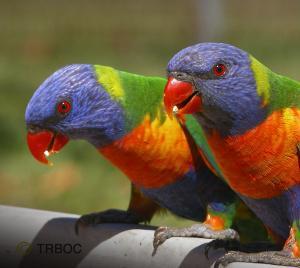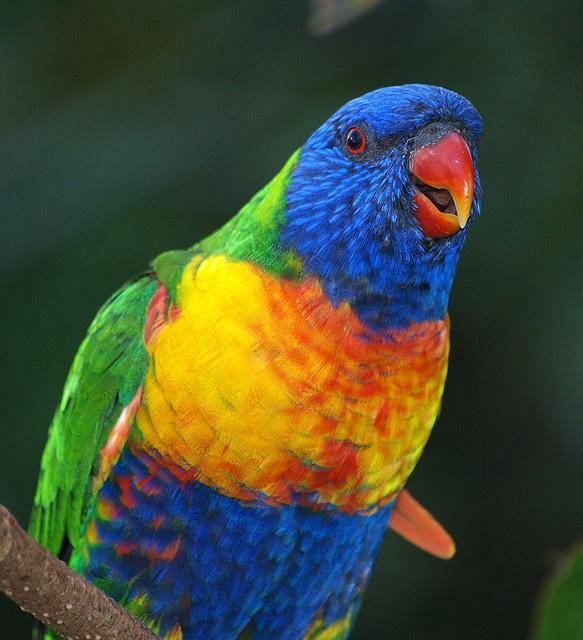The first image is the image on the left, the second image is the image on the right. Evaluate the accuracy of this statement regarding the images: "There are exactly two birds in the image on the left.". Is it true? Answer yes or no. Yes. The first image is the image on the left, the second image is the image on the right. For the images shown, is this caption "More than one bird is visible, even if only partially." true? Answer yes or no. Yes. 